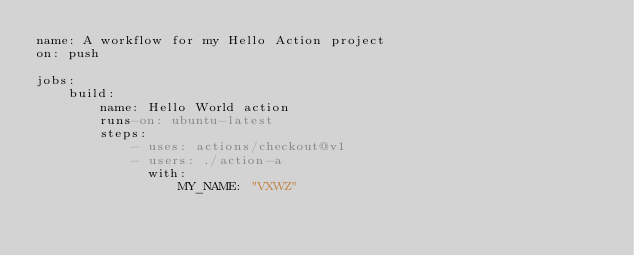<code> <loc_0><loc_0><loc_500><loc_500><_YAML_>name: A workflow for my Hello Action project
on: push

jobs:
    build:
        name: Hello World action
        runs-on: ubuntu-latest
        steps:
            - uses: actions/checkout@v1
            - users: ./action-a
              with:
                  MY_NAME: "VXWZ"

</code> 